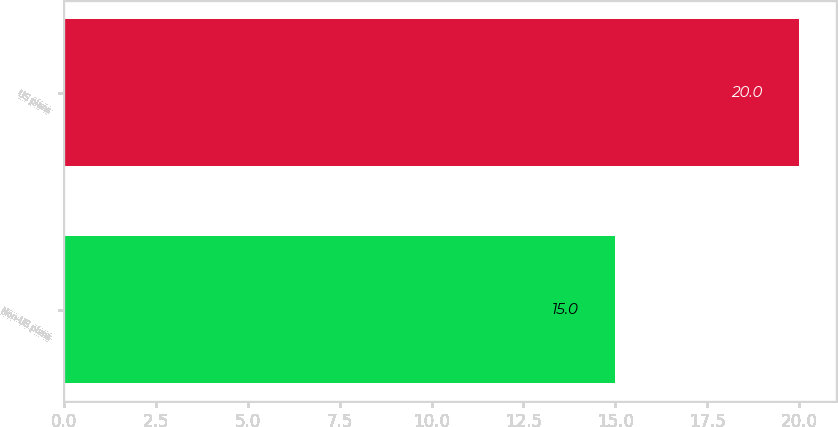Convert chart to OTSL. <chart><loc_0><loc_0><loc_500><loc_500><bar_chart><fcel>Non-US plans<fcel>US plans<nl><fcel>15<fcel>20<nl></chart> 